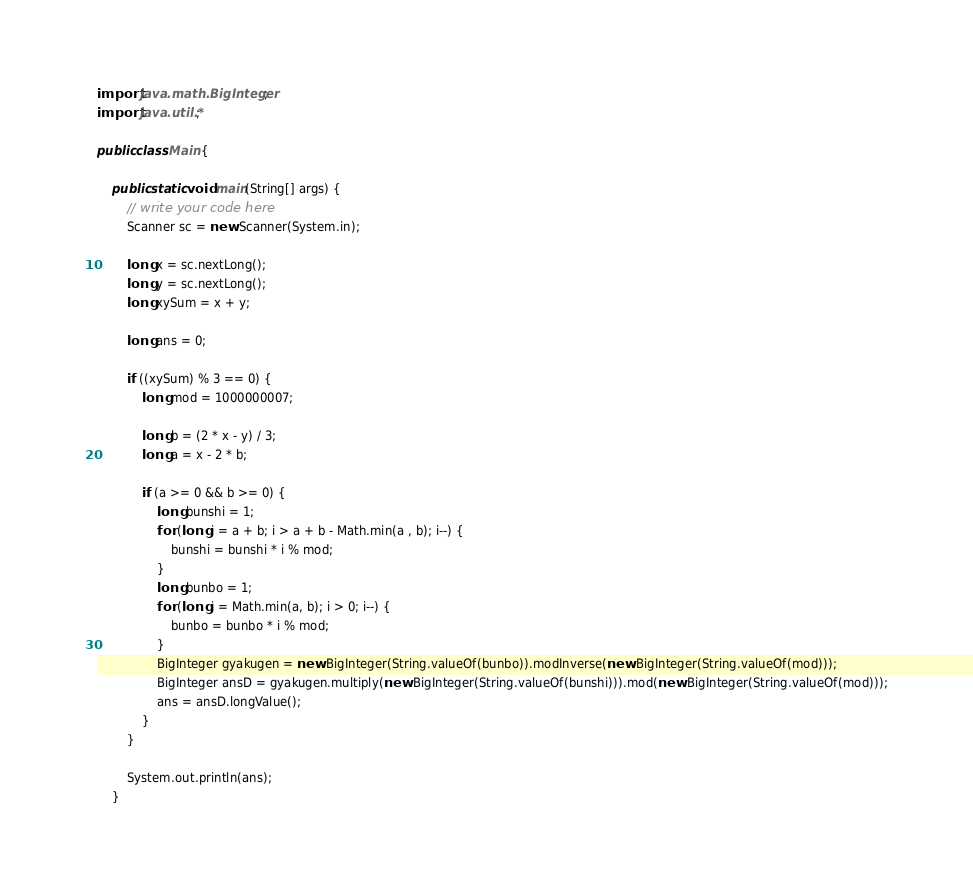Convert code to text. <code><loc_0><loc_0><loc_500><loc_500><_Java_>import java.math.BigInteger;
import java.util.*;

public class Main {

    public static void main(String[] args) {
        // write your code here
        Scanner sc = new Scanner(System.in);

        long x = sc.nextLong();
        long y = sc.nextLong();
        long xySum = x + y;

        long ans = 0;

        if ((xySum) % 3 == 0) {
            long mod = 1000000007;

            long b = (2 * x - y) / 3;
            long a = x - 2 * b;

            if (a >= 0 && b >= 0) {
                long bunshi = 1;
                for (long i = a + b; i > a + b - Math.min(a , b); i--) {
                    bunshi = bunshi * i % mod;
                }
                long bunbo = 1;
                for (long i = Math.min(a, b); i > 0; i--) {
                    bunbo = bunbo * i % mod;
                }
                BigInteger gyakugen = new BigInteger(String.valueOf(bunbo)).modInverse(new BigInteger(String.valueOf(mod)));
                BigInteger ansD = gyakugen.multiply(new BigInteger(String.valueOf(bunshi))).mod(new BigInteger(String.valueOf(mod)));
                ans = ansD.longValue();
            }
        }

        System.out.println(ans);
    }</code> 